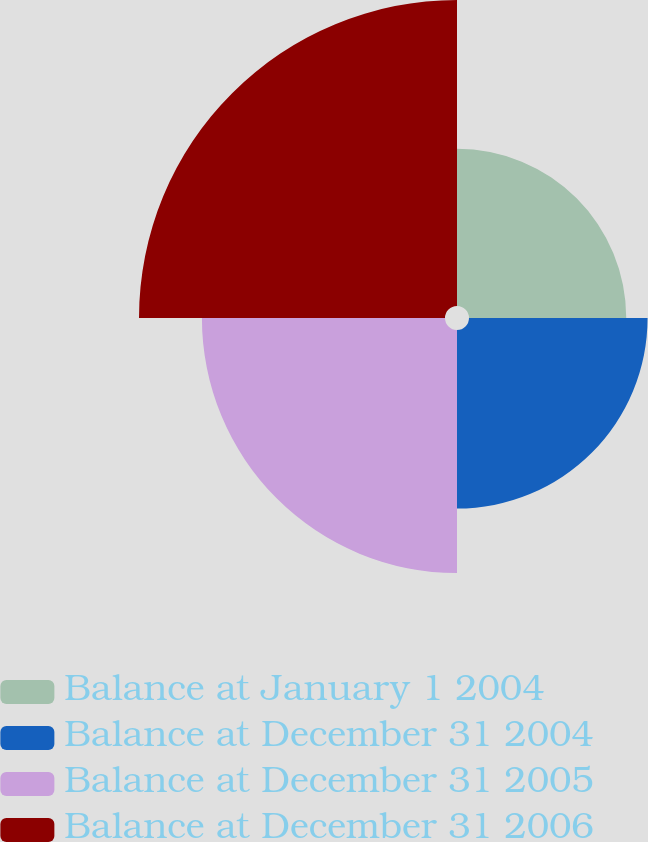Convert chart to OTSL. <chart><loc_0><loc_0><loc_500><loc_500><pie_chart><fcel>Balance at January 1 2004<fcel>Balance at December 31 2004<fcel>Balance at December 31 2005<fcel>Balance at December 31 2006<nl><fcel>17.77%<fcel>20.18%<fcel>27.47%<fcel>34.58%<nl></chart> 